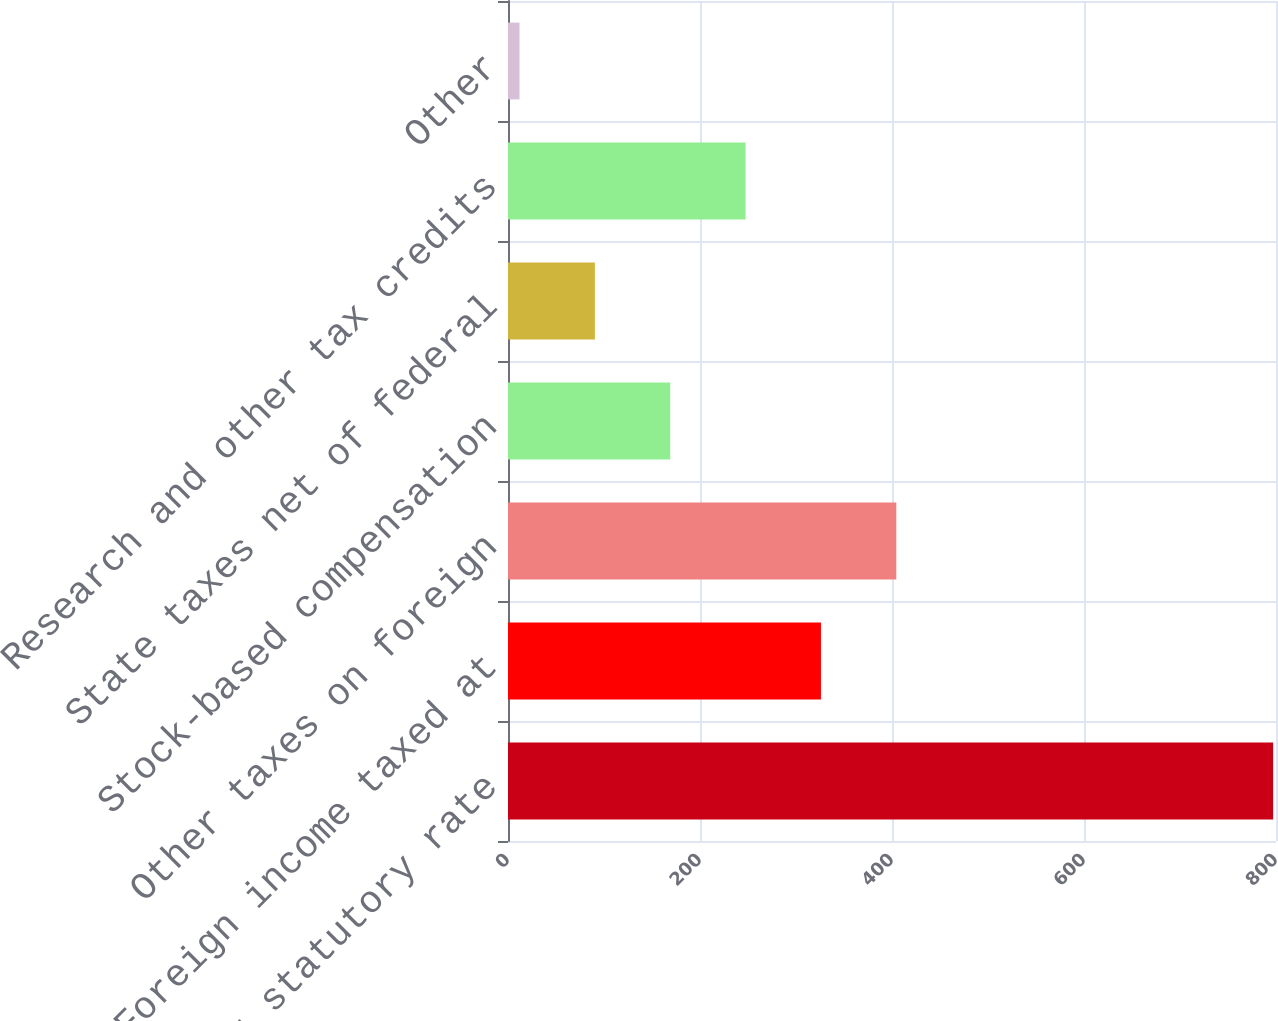<chart> <loc_0><loc_0><loc_500><loc_500><bar_chart><fcel>Provision at statutory rate<fcel>Foreign income taxed at<fcel>Other taxes on foreign<fcel>Stock-based compensation<fcel>State taxes net of federal<fcel>Research and other tax credits<fcel>Other<nl><fcel>797<fcel>326<fcel>404.5<fcel>169<fcel>90.5<fcel>247.5<fcel>12<nl></chart> 